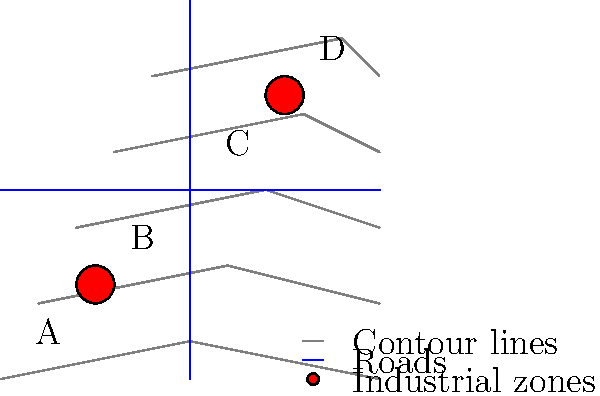Based on the topographical map showing contour lines, roads, and existing automotive industrial zones, which area (A, B, C, or D) would be the most suitable location for a new real estate development project considering accessibility, elevation, and proximity to industrial zones? To determine the most suitable location for a new real estate development project, we need to consider three main factors:

1. Accessibility:
   - Areas B and C are located at the intersection of two major roads, providing better accessibility.
   - Areas A and D are farther from the road intersection, making them less accessible.

2. Elevation:
   - The contour lines represent elevation, with closer lines indicating steeper terrain.
   - Area A has the lowest elevation but is in a flat area.
   - Area B has a moderate elevation with some slope.
   - Area C has a higher elevation with a moderate slope.
   - Area D has the highest elevation with the steepest slope.

3. Proximity to industrial zones:
   - There are two industrial zones marked on the map.
   - Area A is closest to one industrial zone but far from the other.
   - Area B is moderately close to one industrial zone.
   - Area C is moderately close to the other industrial zone.
   - Area D is closest to one industrial zone but far from the other.

Considering these factors:
- Area A is too close to an industrial zone and has poor accessibility.
- Area B offers a good balance of moderate elevation, good accessibility, and reasonable distance from industrial zones.
- Area C has good accessibility but is at a higher elevation with more slope, which could increase construction costs.
- Area D has poor accessibility, the steepest slope, and is too close to an industrial zone.

Therefore, Area B provides the best combination of accessibility, moderate elevation, and appropriate distance from industrial zones for a new real estate development project.
Answer: Area B 